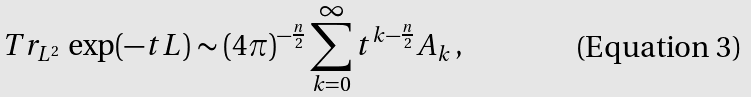Convert formula to latex. <formula><loc_0><loc_0><loc_500><loc_500>T r _ { { L } ^ { 2 } } \, \exp ( - t L ) \sim ( 4 \pi ) ^ { - \frac { n } { 2 } } \sum _ { k = 0 } ^ { \infty } t ^ { k - \frac { n } { 2 } } A _ { k } \, ,</formula> 